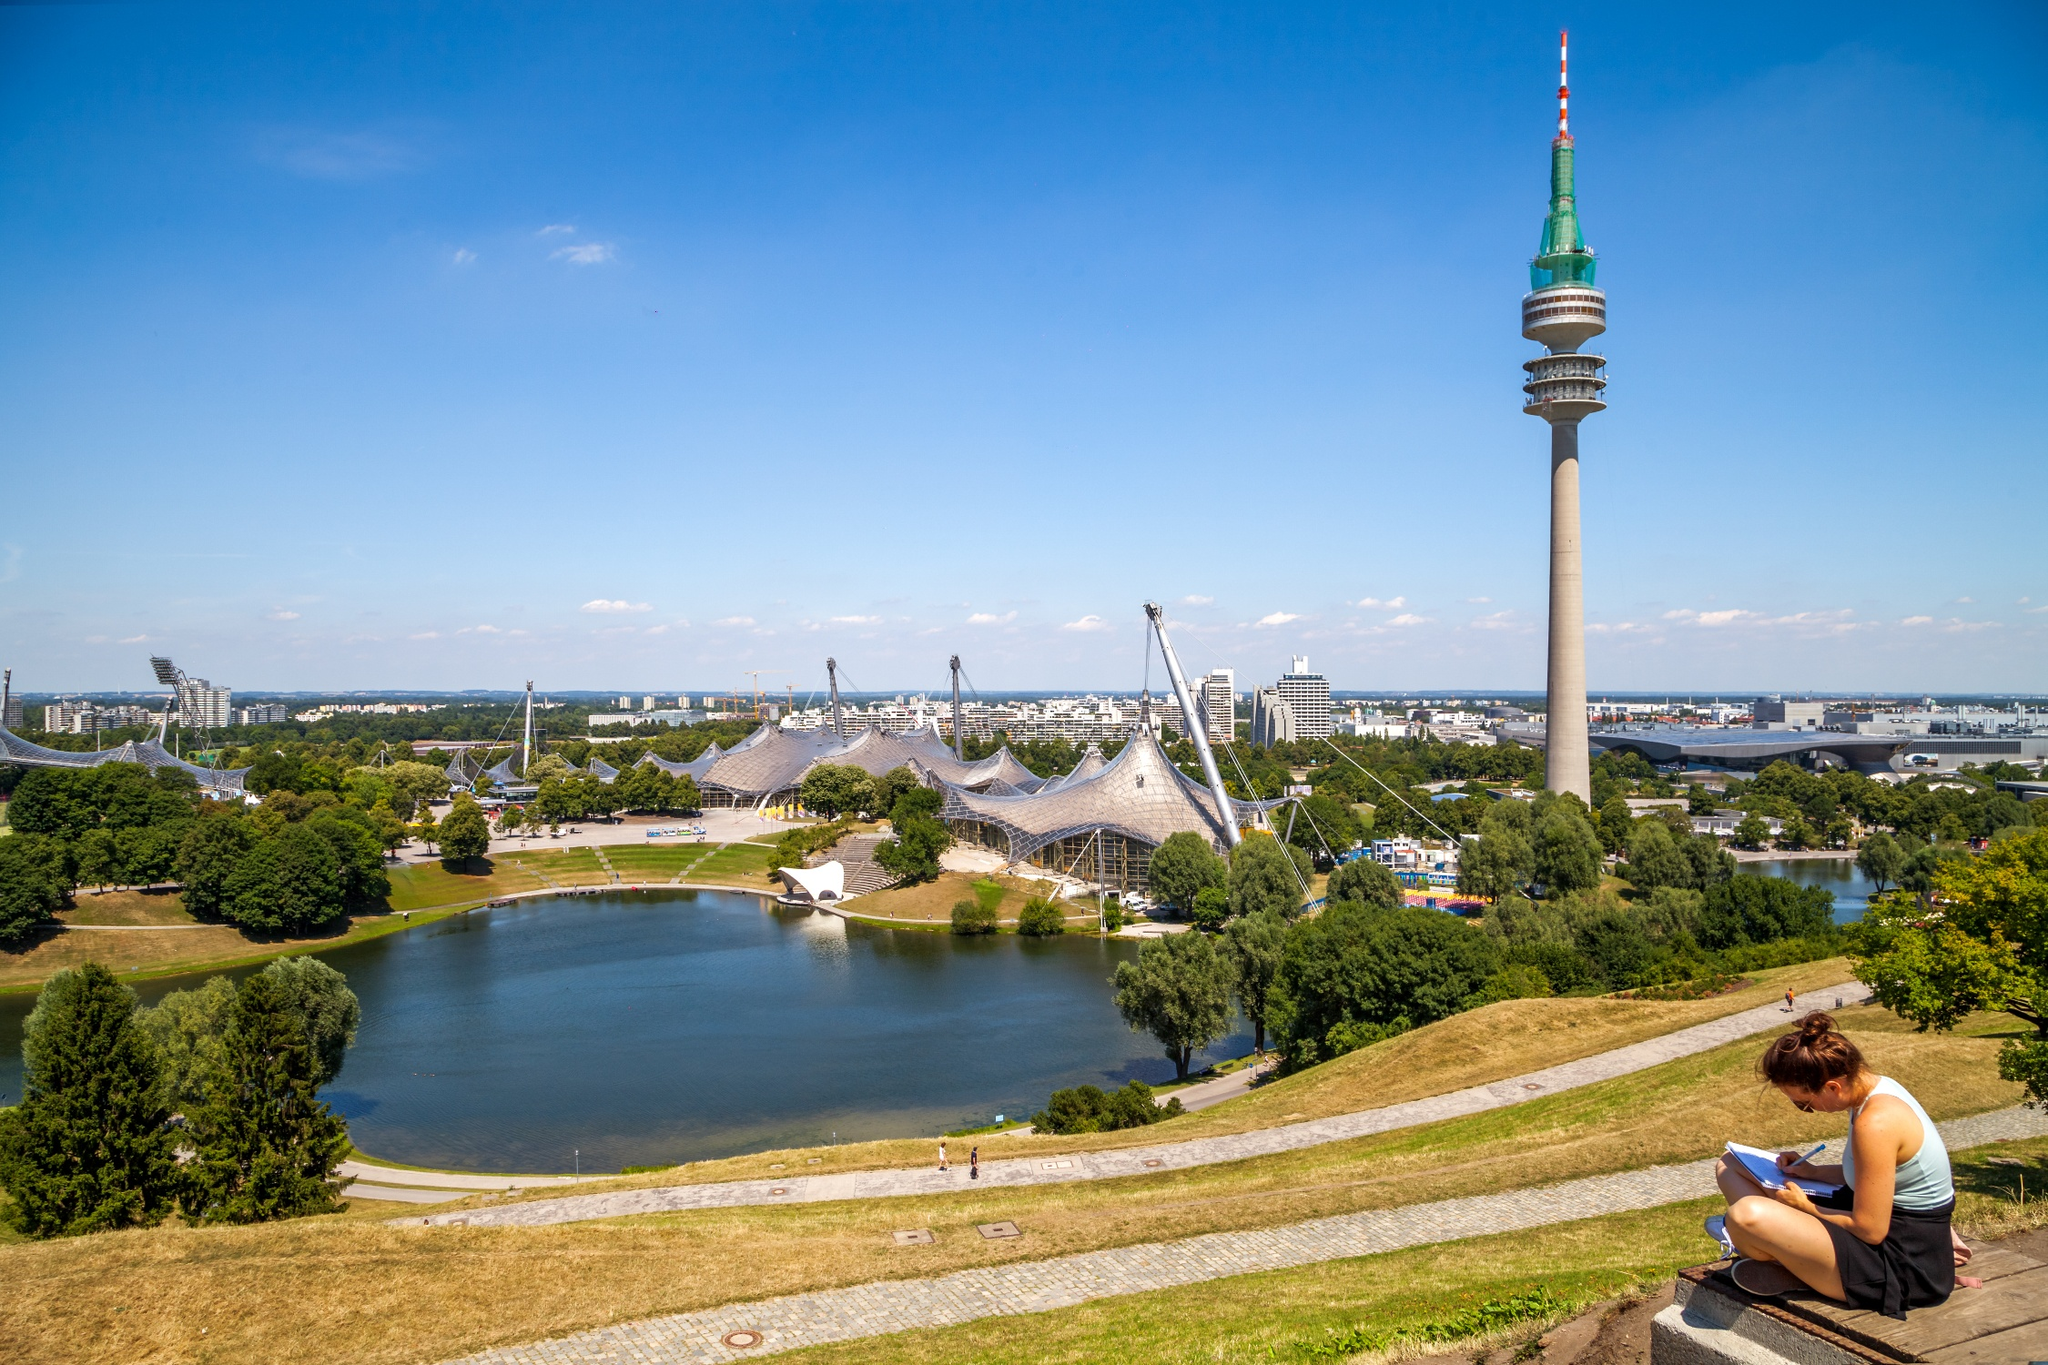Can you tell me about the history of this place? The Olympic Park in Munich was constructed for the 1972 Summer Olympics. It's an architectural marvel, especially renowned for its futuristic design that includes the tent-like structure of the Olympic Stadium. This design was ahead of its time and aimed to symbolize a new, more diplomatic Germany post-WWII. The park and its facilities, including the Olympic Tower, continue to be pivotal landmarks in Munich, hosting a variety of events and offering recreational activities for visitors. 